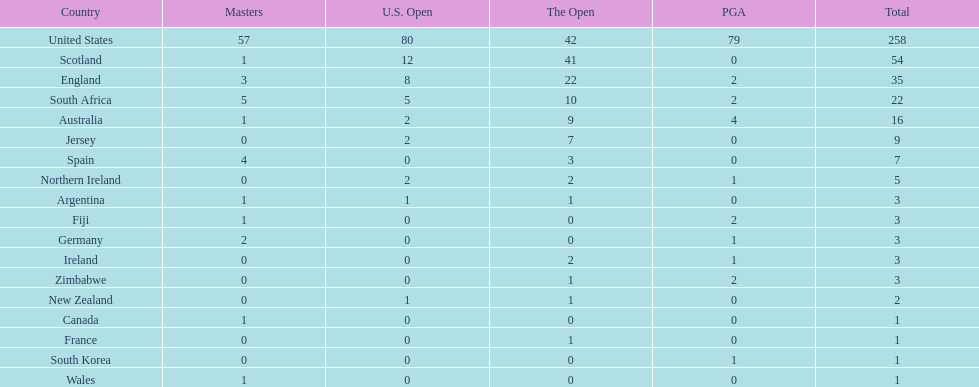Is the united stated or scotland better? United States. 